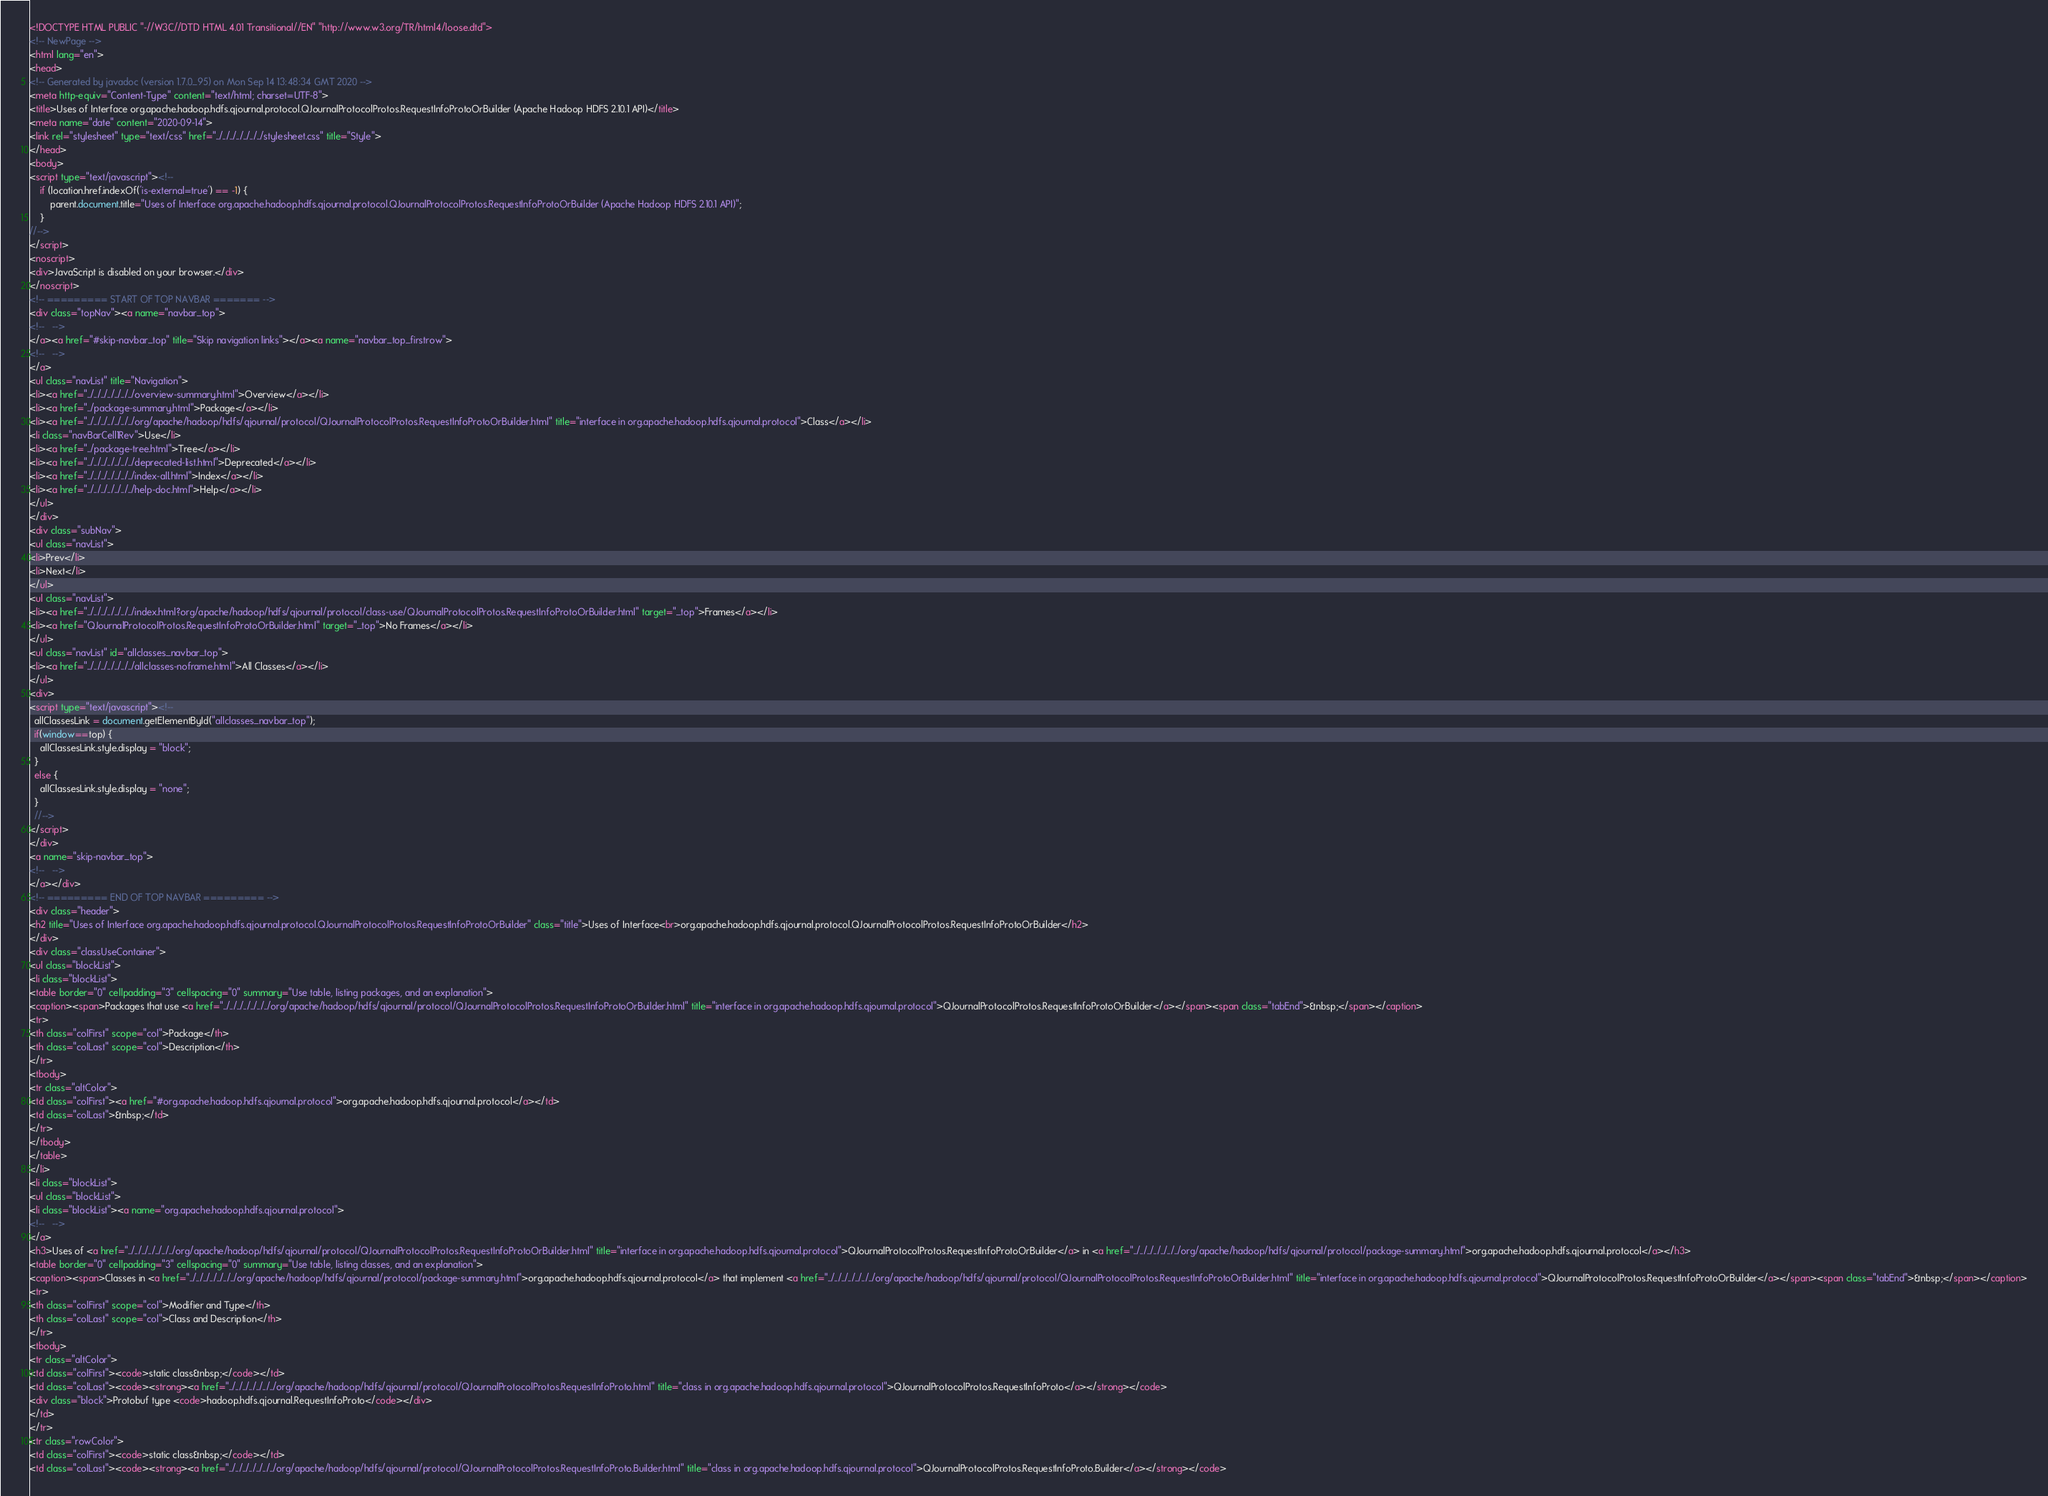Convert code to text. <code><loc_0><loc_0><loc_500><loc_500><_HTML_><!DOCTYPE HTML PUBLIC "-//W3C//DTD HTML 4.01 Transitional//EN" "http://www.w3.org/TR/html4/loose.dtd">
<!-- NewPage -->
<html lang="en">
<head>
<!-- Generated by javadoc (version 1.7.0_95) on Mon Sep 14 13:48:34 GMT 2020 -->
<meta http-equiv="Content-Type" content="text/html; charset=UTF-8">
<title>Uses of Interface org.apache.hadoop.hdfs.qjournal.protocol.QJournalProtocolProtos.RequestInfoProtoOrBuilder (Apache Hadoop HDFS 2.10.1 API)</title>
<meta name="date" content="2020-09-14">
<link rel="stylesheet" type="text/css" href="../../../../../../../stylesheet.css" title="Style">
</head>
<body>
<script type="text/javascript"><!--
    if (location.href.indexOf('is-external=true') == -1) {
        parent.document.title="Uses of Interface org.apache.hadoop.hdfs.qjournal.protocol.QJournalProtocolProtos.RequestInfoProtoOrBuilder (Apache Hadoop HDFS 2.10.1 API)";
    }
//-->
</script>
<noscript>
<div>JavaScript is disabled on your browser.</div>
</noscript>
<!-- ========= START OF TOP NAVBAR ======= -->
<div class="topNav"><a name="navbar_top">
<!--   -->
</a><a href="#skip-navbar_top" title="Skip navigation links"></a><a name="navbar_top_firstrow">
<!--   -->
</a>
<ul class="navList" title="Navigation">
<li><a href="../../../../../../../overview-summary.html">Overview</a></li>
<li><a href="../package-summary.html">Package</a></li>
<li><a href="../../../../../../../org/apache/hadoop/hdfs/qjournal/protocol/QJournalProtocolProtos.RequestInfoProtoOrBuilder.html" title="interface in org.apache.hadoop.hdfs.qjournal.protocol">Class</a></li>
<li class="navBarCell1Rev">Use</li>
<li><a href="../package-tree.html">Tree</a></li>
<li><a href="../../../../../../../deprecated-list.html">Deprecated</a></li>
<li><a href="../../../../../../../index-all.html">Index</a></li>
<li><a href="../../../../../../../help-doc.html">Help</a></li>
</ul>
</div>
<div class="subNav">
<ul class="navList">
<li>Prev</li>
<li>Next</li>
</ul>
<ul class="navList">
<li><a href="../../../../../../../index.html?org/apache/hadoop/hdfs/qjournal/protocol/class-use/QJournalProtocolProtos.RequestInfoProtoOrBuilder.html" target="_top">Frames</a></li>
<li><a href="QJournalProtocolProtos.RequestInfoProtoOrBuilder.html" target="_top">No Frames</a></li>
</ul>
<ul class="navList" id="allclasses_navbar_top">
<li><a href="../../../../../../../allclasses-noframe.html">All Classes</a></li>
</ul>
<div>
<script type="text/javascript"><!--
  allClassesLink = document.getElementById("allclasses_navbar_top");
  if(window==top) {
    allClassesLink.style.display = "block";
  }
  else {
    allClassesLink.style.display = "none";
  }
  //-->
</script>
</div>
<a name="skip-navbar_top">
<!--   -->
</a></div>
<!-- ========= END OF TOP NAVBAR ========= -->
<div class="header">
<h2 title="Uses of Interface org.apache.hadoop.hdfs.qjournal.protocol.QJournalProtocolProtos.RequestInfoProtoOrBuilder" class="title">Uses of Interface<br>org.apache.hadoop.hdfs.qjournal.protocol.QJournalProtocolProtos.RequestInfoProtoOrBuilder</h2>
</div>
<div class="classUseContainer">
<ul class="blockList">
<li class="blockList">
<table border="0" cellpadding="3" cellspacing="0" summary="Use table, listing packages, and an explanation">
<caption><span>Packages that use <a href="../../../../../../../org/apache/hadoop/hdfs/qjournal/protocol/QJournalProtocolProtos.RequestInfoProtoOrBuilder.html" title="interface in org.apache.hadoop.hdfs.qjournal.protocol">QJournalProtocolProtos.RequestInfoProtoOrBuilder</a></span><span class="tabEnd">&nbsp;</span></caption>
<tr>
<th class="colFirst" scope="col">Package</th>
<th class="colLast" scope="col">Description</th>
</tr>
<tbody>
<tr class="altColor">
<td class="colFirst"><a href="#org.apache.hadoop.hdfs.qjournal.protocol">org.apache.hadoop.hdfs.qjournal.protocol</a></td>
<td class="colLast">&nbsp;</td>
</tr>
</tbody>
</table>
</li>
<li class="blockList">
<ul class="blockList">
<li class="blockList"><a name="org.apache.hadoop.hdfs.qjournal.protocol">
<!--   -->
</a>
<h3>Uses of <a href="../../../../../../../org/apache/hadoop/hdfs/qjournal/protocol/QJournalProtocolProtos.RequestInfoProtoOrBuilder.html" title="interface in org.apache.hadoop.hdfs.qjournal.protocol">QJournalProtocolProtos.RequestInfoProtoOrBuilder</a> in <a href="../../../../../../../org/apache/hadoop/hdfs/qjournal/protocol/package-summary.html">org.apache.hadoop.hdfs.qjournal.protocol</a></h3>
<table border="0" cellpadding="3" cellspacing="0" summary="Use table, listing classes, and an explanation">
<caption><span>Classes in <a href="../../../../../../../org/apache/hadoop/hdfs/qjournal/protocol/package-summary.html">org.apache.hadoop.hdfs.qjournal.protocol</a> that implement <a href="../../../../../../../org/apache/hadoop/hdfs/qjournal/protocol/QJournalProtocolProtos.RequestInfoProtoOrBuilder.html" title="interface in org.apache.hadoop.hdfs.qjournal.protocol">QJournalProtocolProtos.RequestInfoProtoOrBuilder</a></span><span class="tabEnd">&nbsp;</span></caption>
<tr>
<th class="colFirst" scope="col">Modifier and Type</th>
<th class="colLast" scope="col">Class and Description</th>
</tr>
<tbody>
<tr class="altColor">
<td class="colFirst"><code>static class&nbsp;</code></td>
<td class="colLast"><code><strong><a href="../../../../../../../org/apache/hadoop/hdfs/qjournal/protocol/QJournalProtocolProtos.RequestInfoProto.html" title="class in org.apache.hadoop.hdfs.qjournal.protocol">QJournalProtocolProtos.RequestInfoProto</a></strong></code>
<div class="block">Protobuf type <code>hadoop.hdfs.qjournal.RequestInfoProto</code></div>
</td>
</tr>
<tr class="rowColor">
<td class="colFirst"><code>static class&nbsp;</code></td>
<td class="colLast"><code><strong><a href="../../../../../../../org/apache/hadoop/hdfs/qjournal/protocol/QJournalProtocolProtos.RequestInfoProto.Builder.html" title="class in org.apache.hadoop.hdfs.qjournal.protocol">QJournalProtocolProtos.RequestInfoProto.Builder</a></strong></code></code> 